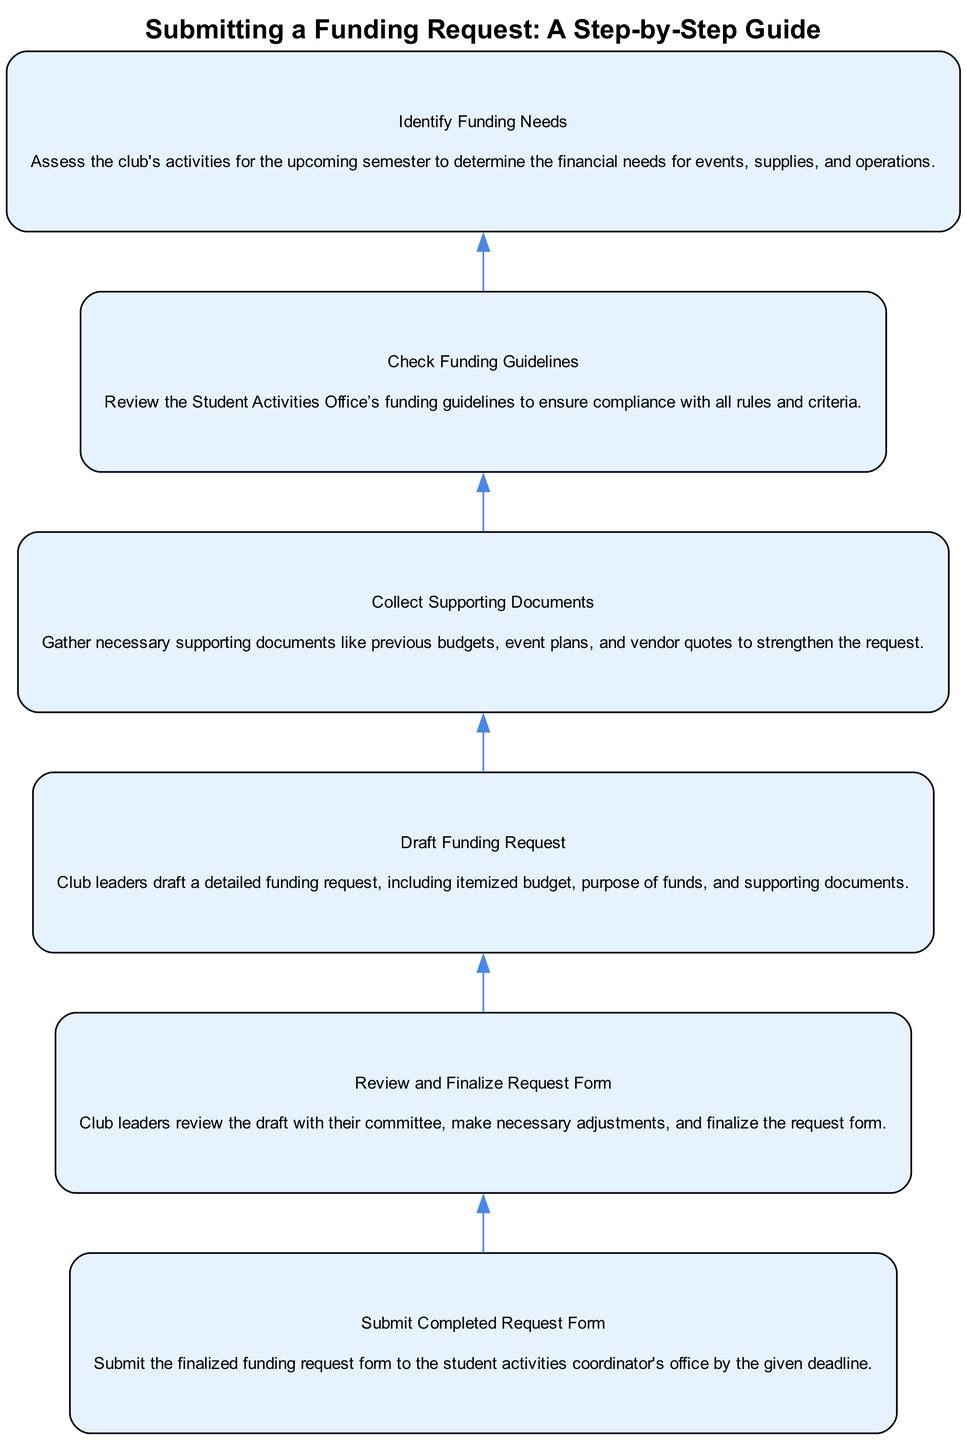What is the first step in the funding request process? The diagram shows that the first step is to "Identify Funding Needs," which is the lowest node in the flow chart.
Answer: Identify Funding Needs How many total steps are there in the funding request process? By counting the nodes in the diagram that represent individual steps, there are six steps listed sequentially from bottom to top.
Answer: Six What should club leaders do after drafting the funding request? According to the diagram, after drafting the funding request, leaders should "Collect Supporting Documents," which is the next node above.
Answer: Collect Supporting Documents What is the final step that must be completed? The last node in the diagram indicates that the final step is to "Submit Completed Request Form," which is positioned at the top of the flow chart.
Answer: Submit Completed Request Form What is one document needed for the funding request? From the diagram, one type of supporting document needed is "vendor quotes," as mentioned in the description of the "Collect Supporting Documents" step.
Answer: Vendor quotes What comes before "Review and Finalize Request Form"? The step immediately preceding "Review and Finalize Request Form" is "Draft Funding Request," which is the second node from the bottom in the flow.
Answer: Draft Funding Request Why is it important to check funding guidelines? The diagram indicates that checking the funding guidelines ensures compliance with all rules and criteria, which is a critical step before identifying funding needs.
Answer: Compliance with rules What type of documents should be gathered before submitting a request? According to the "Collect Supporting Documents" step in the diagram, necessary documents include "previous budgets, event plans, and vendor quotes," which support the funding request.
Answer: Previous budgets, event plans, and vendor quotes 